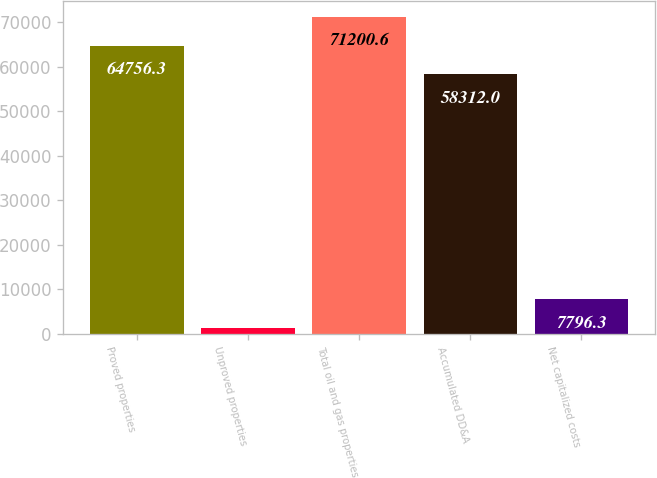<chart> <loc_0><loc_0><loc_500><loc_500><bar_chart><fcel>Proved properties<fcel>Unproved properties<fcel>Total oil and gas properties<fcel>Accumulated DD&A<fcel>Net capitalized costs<nl><fcel>64756.3<fcel>1352<fcel>71200.6<fcel>58312<fcel>7796.3<nl></chart> 